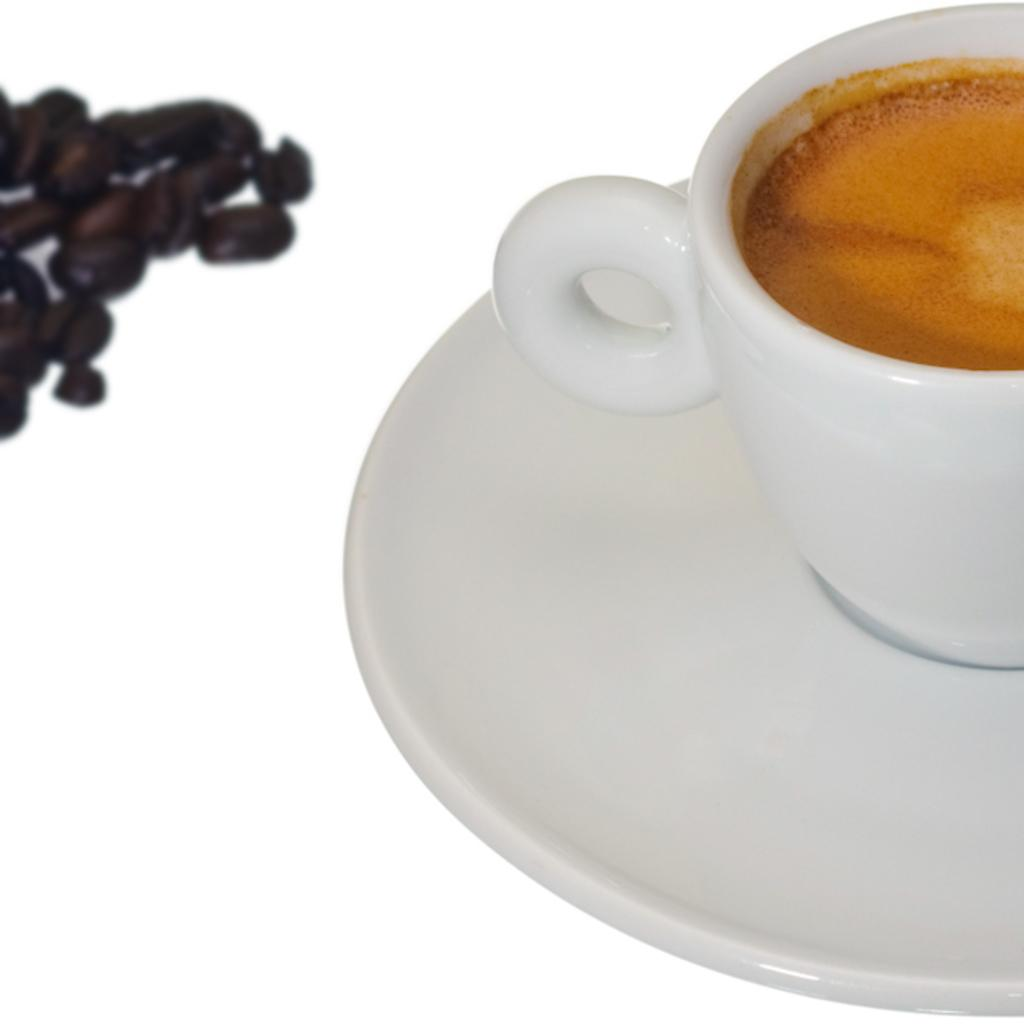What is in the cup that is visible in the image? There is a cup with coffee in the image. What accompanies the cup in the image? There is a saucer in the image. What other coffee-related items can be seen in the image? Coffee beans are visible in the image. What is the color of the background in the image? The background of the image is white. Where is the boy standing in the image? There is no boy present in the image. What type of gate can be seen in the image? There is no gate present in the image. 